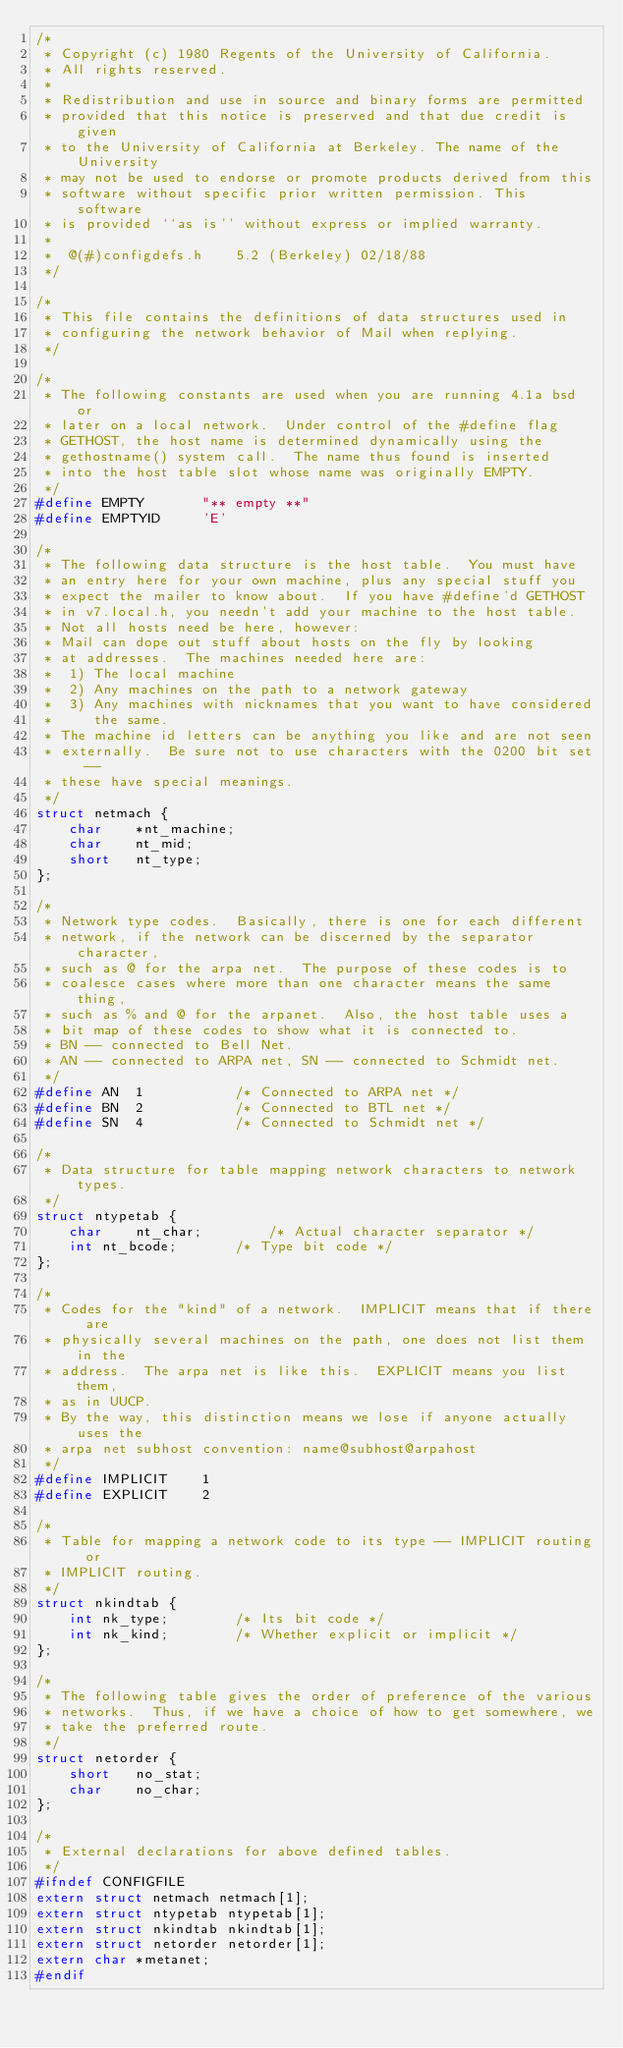<code> <loc_0><loc_0><loc_500><loc_500><_C_>/*
 * Copyright (c) 1980 Regents of the University of California.
 * All rights reserved.
 *
 * Redistribution and use in source and binary forms are permitted
 * provided that this notice is preserved and that due credit is given
 * to the University of California at Berkeley. The name of the University
 * may not be used to endorse or promote products derived from this
 * software without specific prior written permission. This software
 * is provided ``as is'' without express or implied warranty.
 *
 *	@(#)configdefs.h	5.2 (Berkeley) 02/18/88
 */

/*
 * This file contains the definitions of data structures used in
 * configuring the network behavior of Mail when replying.
 */

/*
 * The following constants are used when you are running 4.1a bsd or
 * later on a local network.  Under control of the #define flag
 * GETHOST, the host name is determined dynamically using the
 * gethostname() system call.  The name thus found is inserted
 * into the host table slot whose name was originally EMPTY.
 */
#define	EMPTY		"** empty **"
#define	EMPTYID		'E'

/*
 * The following data structure is the host table.  You must have
 * an entry here for your own machine, plus any special stuff you
 * expect the mailer to know about.  If you have #define'd GETHOST
 * in v7.local.h, you needn't add your machine to the host table.
 * Not all hosts need be here, however:
 * Mail can dope out stuff about hosts on the fly by looking
 * at addresses.  The machines needed here are:
 *	1) The local machine
 *	2) Any machines on the path to a network gateway
 *	3) Any machines with nicknames that you want to have considered
 *	   the same.
 * The machine id letters can be anything you like and are not seen
 * externally.  Be sure not to use characters with the 0200 bit set --
 * these have special meanings.
 */
struct netmach {
	char	*nt_machine;
	char	nt_mid;
	short	nt_type;
};

/*
 * Network type codes.  Basically, there is one for each different
 * network, if the network can be discerned by the separator character,
 * such as @ for the arpa net.  The purpose of these codes is to
 * coalesce cases where more than one character means the same thing,
 * such as % and @ for the arpanet.  Also, the host table uses a
 * bit map of these codes to show what it is connected to.
 * BN -- connected to Bell Net.
 * AN -- connected to ARPA net, SN -- connected to Schmidt net.
 */
#define	AN	1			/* Connected to ARPA net */
#define	BN	2			/* Connected to BTL net */
#define	SN	4			/* Connected to Schmidt net */

/*
 * Data structure for table mapping network characters to network types.
 */
struct ntypetab {
	char	nt_char;		/* Actual character separator */
	int	nt_bcode;		/* Type bit code */
};

/*
 * Codes for the "kind" of a network.  IMPLICIT means that if there are
 * physically several machines on the path, one does not list them in the
 * address.  The arpa net is like this.  EXPLICIT means you list them,
 * as in UUCP.
 * By the way, this distinction means we lose if anyone actually uses the
 * arpa net subhost convention: name@subhost@arpahost
 */
#define	IMPLICIT	1
#define	EXPLICIT	2

/*
 * Table for mapping a network code to its type -- IMPLICIT routing or
 * IMPLICIT routing.
 */
struct nkindtab {
	int	nk_type;		/* Its bit code */
	int	nk_kind;		/* Whether explicit or implicit */
};

/*
 * The following table gives the order of preference of the various
 * networks.  Thus, if we have a choice of how to get somewhere, we
 * take the preferred route.
 */
struct netorder {
	short	no_stat;
	char	no_char;
};

/*
 * External declarations for above defined tables.
 */
#ifndef CONFIGFILE
extern struct netmach netmach[1];
extern struct ntypetab ntypetab[1];
extern struct nkindtab nkindtab[1];
extern struct netorder netorder[1];
extern char *metanet;
#endif
</code> 